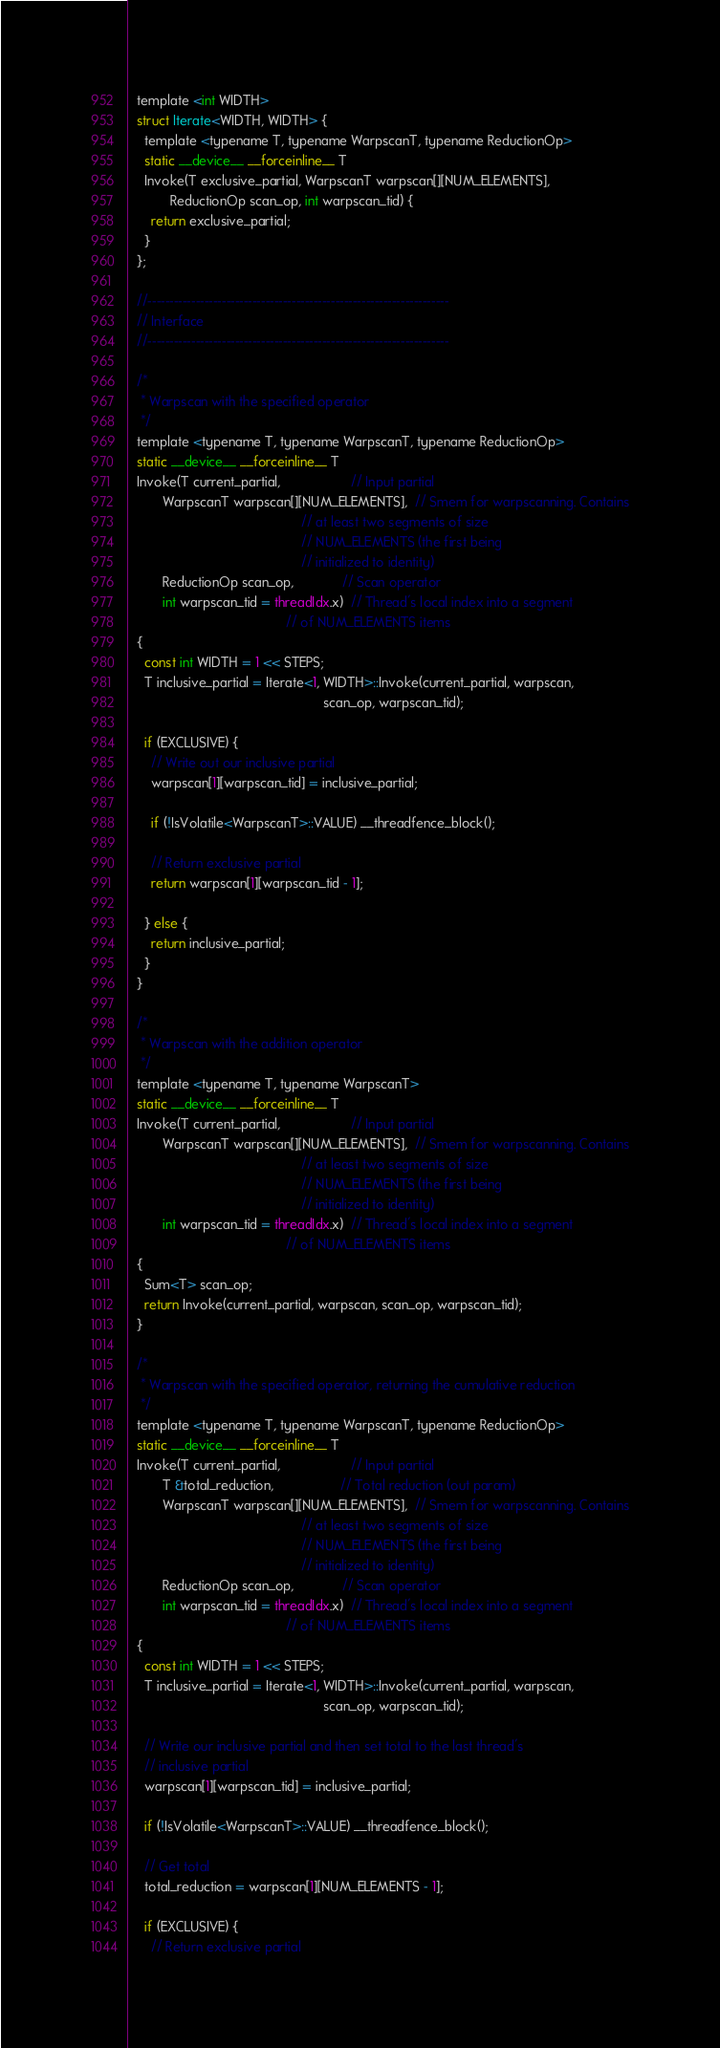Convert code to text. <code><loc_0><loc_0><loc_500><loc_500><_Cuda_>  template <int WIDTH>
  struct Iterate<WIDTH, WIDTH> {
    template <typename T, typename WarpscanT, typename ReductionOp>
    static __device__ __forceinline__ T
    Invoke(T exclusive_partial, WarpscanT warpscan[][NUM_ELEMENTS],
           ReductionOp scan_op, int warpscan_tid) {
      return exclusive_partial;
    }
  };

  //---------------------------------------------------------------------
  // Interface
  //---------------------------------------------------------------------

  /*
   * Warpscan with the specified operator
   */
  template <typename T, typename WarpscanT, typename ReductionOp>
  static __device__ __forceinline__ T
  Invoke(T current_partial,                   // Input partial
         WarpscanT warpscan[][NUM_ELEMENTS],  // Smem for warpscanning. Contains
                                              // at least two segments of size
                                              // NUM_ELEMENTS (the first being
                                              // initialized to identity)
         ReductionOp scan_op,             // Scan operator
         int warpscan_tid = threadIdx.x)  // Thread's local index into a segment
                                          // of NUM_ELEMENTS items
  {
    const int WIDTH = 1 << STEPS;
    T inclusive_partial = Iterate<1, WIDTH>::Invoke(current_partial, warpscan,
                                                    scan_op, warpscan_tid);

    if (EXCLUSIVE) {
      // Write out our inclusive partial
      warpscan[1][warpscan_tid] = inclusive_partial;

      if (!IsVolatile<WarpscanT>::VALUE) __threadfence_block();

      // Return exclusive partial
      return warpscan[1][warpscan_tid - 1];

    } else {
      return inclusive_partial;
    }
  }

  /*
   * Warpscan with the addition operator
   */
  template <typename T, typename WarpscanT>
  static __device__ __forceinline__ T
  Invoke(T current_partial,                   // Input partial
         WarpscanT warpscan[][NUM_ELEMENTS],  // Smem for warpscanning. Contains
                                              // at least two segments of size
                                              // NUM_ELEMENTS (the first being
                                              // initialized to identity)
         int warpscan_tid = threadIdx.x)  // Thread's local index into a segment
                                          // of NUM_ELEMENTS items
  {
    Sum<T> scan_op;
    return Invoke(current_partial, warpscan, scan_op, warpscan_tid);
  }

  /*
   * Warpscan with the specified operator, returning the cumulative reduction
   */
  template <typename T, typename WarpscanT, typename ReductionOp>
  static __device__ __forceinline__ T
  Invoke(T current_partial,                   // Input partial
         T &total_reduction,                  // Total reduction (out param)
         WarpscanT warpscan[][NUM_ELEMENTS],  // Smem for warpscanning. Contains
                                              // at least two segments of size
                                              // NUM_ELEMENTS (the first being
                                              // initialized to identity)
         ReductionOp scan_op,             // Scan operator
         int warpscan_tid = threadIdx.x)  // Thread's local index into a segment
                                          // of NUM_ELEMENTS items
  {
    const int WIDTH = 1 << STEPS;
    T inclusive_partial = Iterate<1, WIDTH>::Invoke(current_partial, warpscan,
                                                    scan_op, warpscan_tid);

    // Write our inclusive partial and then set total to the last thread's
    // inclusive partial
    warpscan[1][warpscan_tid] = inclusive_partial;

    if (!IsVolatile<WarpscanT>::VALUE) __threadfence_block();

    // Get total
    total_reduction = warpscan[1][NUM_ELEMENTS - 1];

    if (EXCLUSIVE) {
      // Return exclusive partial</code> 